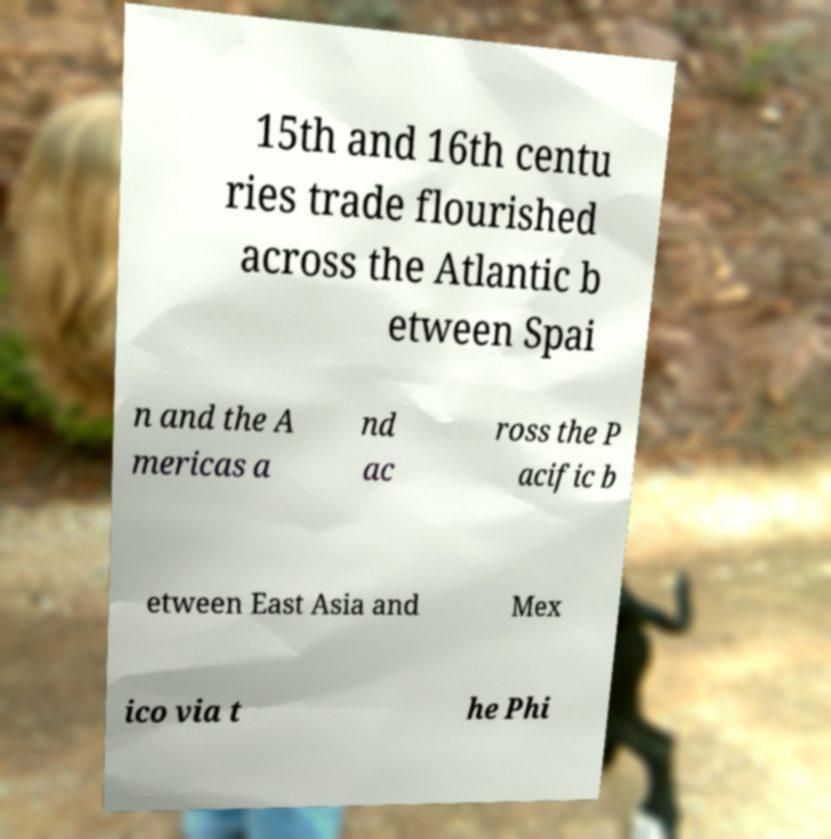Could you assist in decoding the text presented in this image and type it out clearly? 15th and 16th centu ries trade flourished across the Atlantic b etween Spai n and the A mericas a nd ac ross the P acific b etween East Asia and Mex ico via t he Phi 